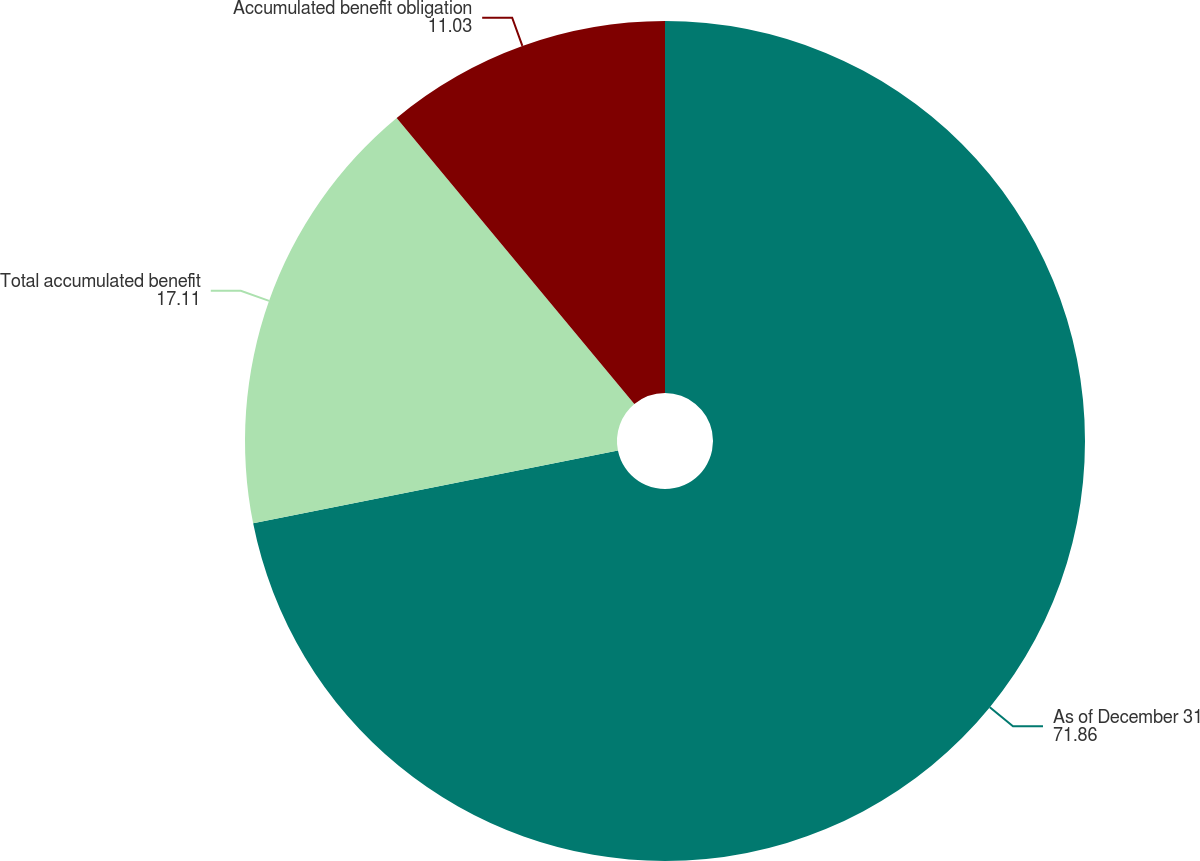Convert chart. <chart><loc_0><loc_0><loc_500><loc_500><pie_chart><fcel>As of December 31<fcel>Total accumulated benefit<fcel>Accumulated benefit obligation<nl><fcel>71.86%<fcel>17.11%<fcel>11.03%<nl></chart> 